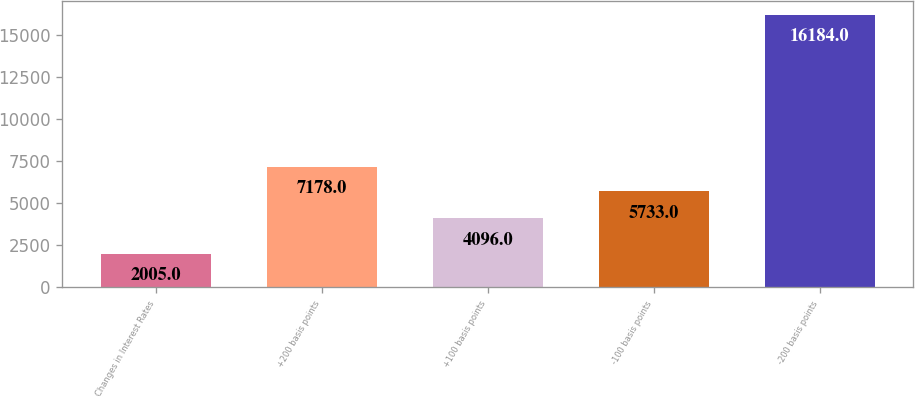Convert chart. <chart><loc_0><loc_0><loc_500><loc_500><bar_chart><fcel>Changes in Interest Rates<fcel>+200 basis points<fcel>+100 basis points<fcel>-100 basis points<fcel>-200 basis points<nl><fcel>2005<fcel>7178<fcel>4096<fcel>5733<fcel>16184<nl></chart> 